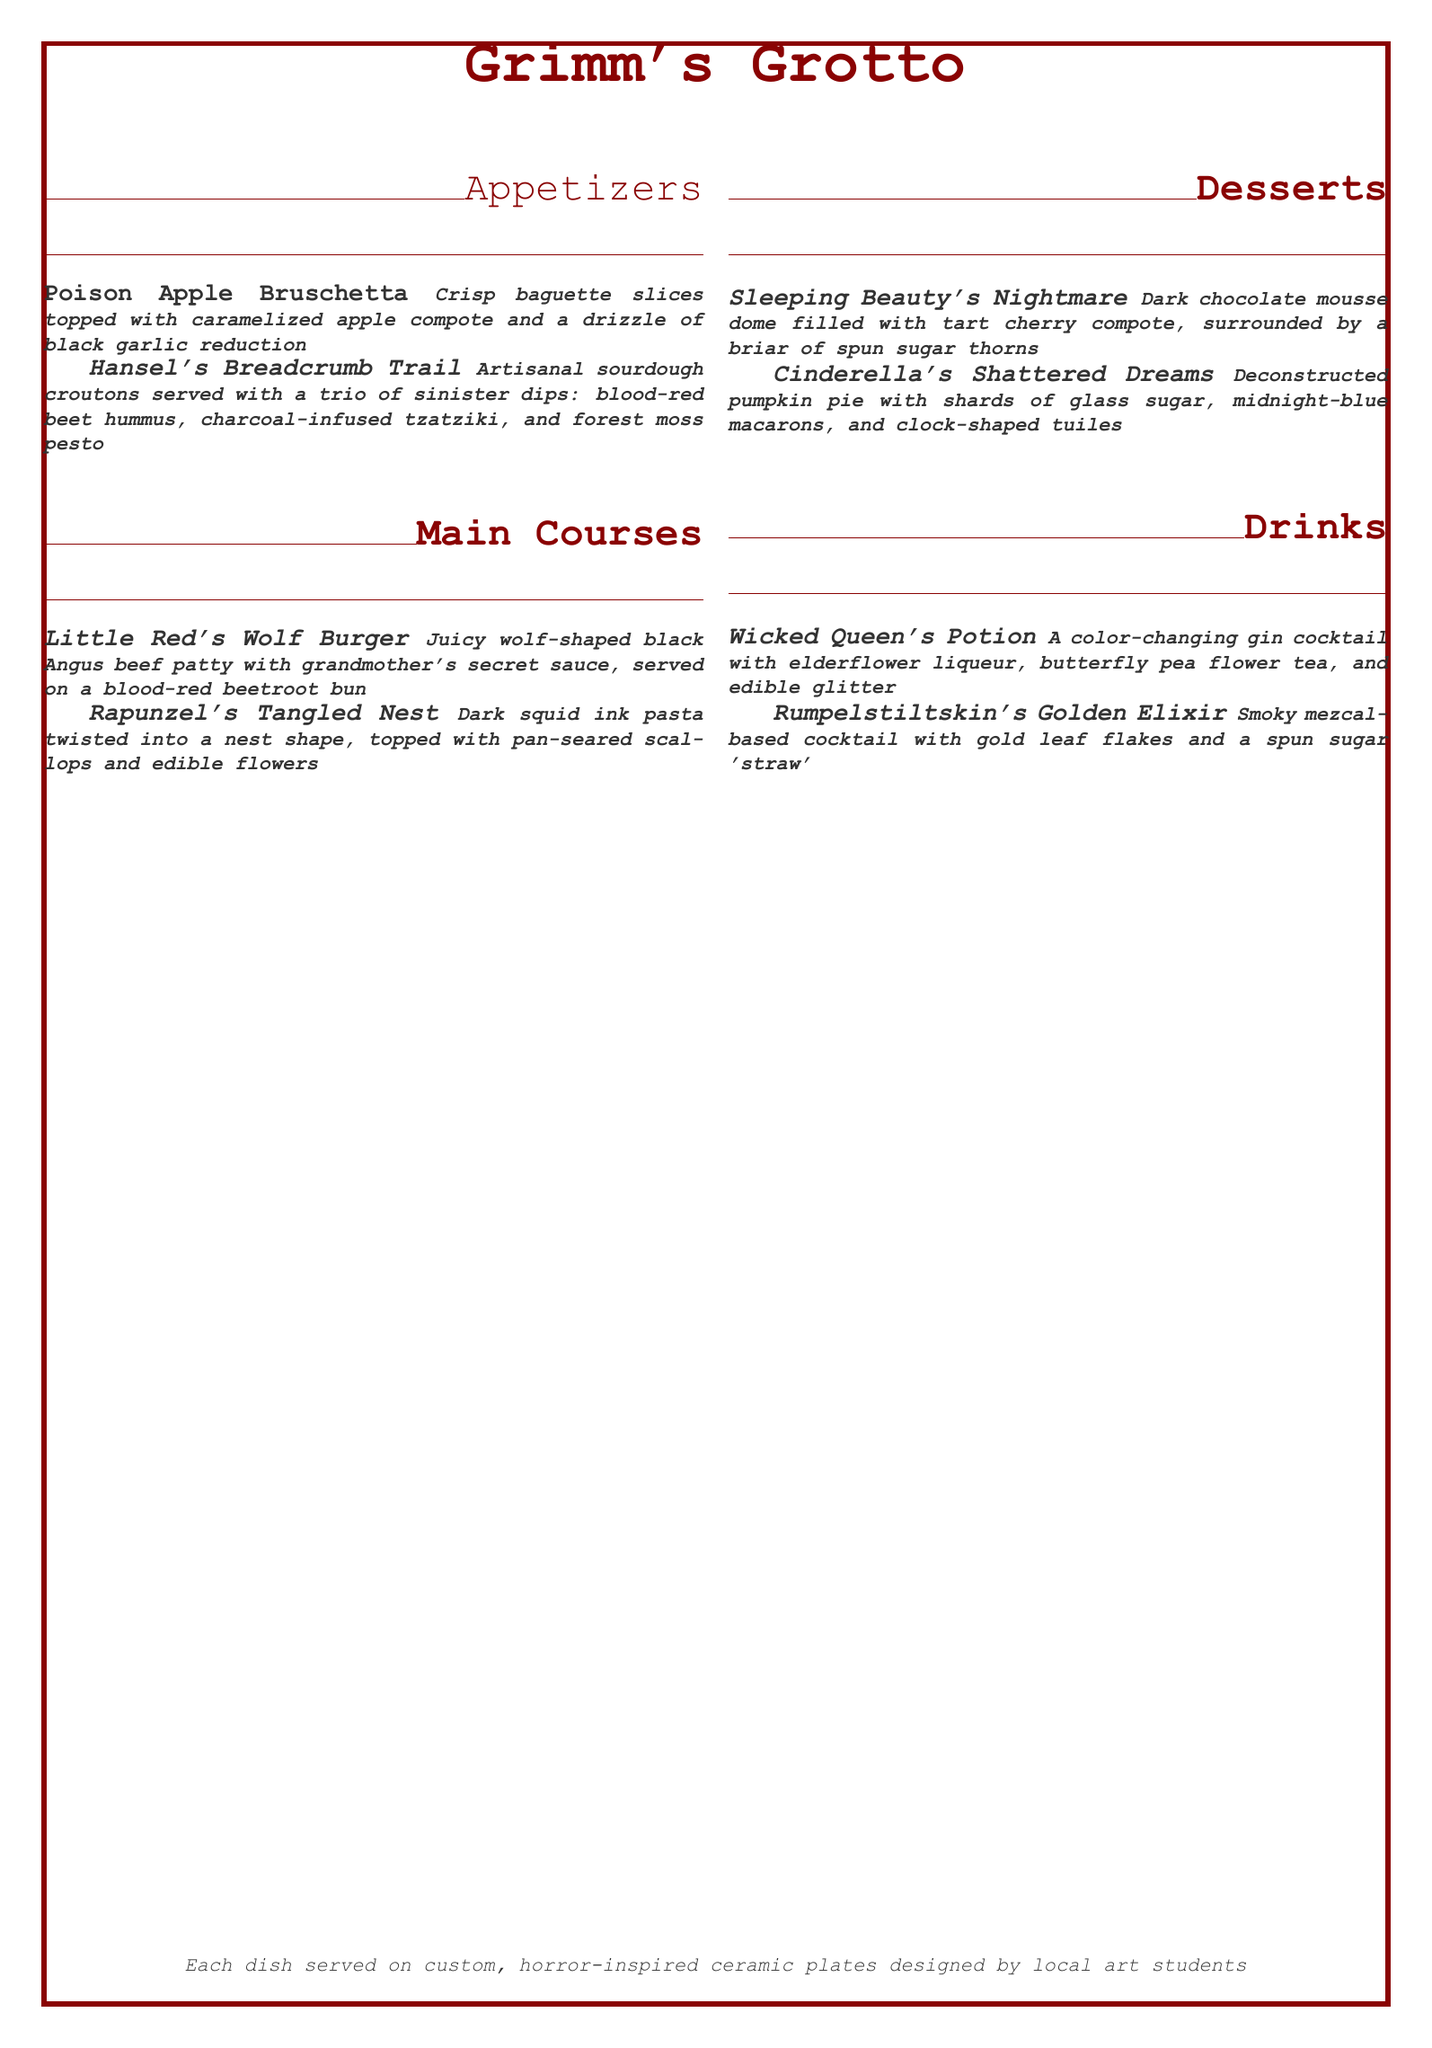What is the title of the menu? The title of the menu is prominently featured at the top of the document, which is Grimm's Grotto.
Answer: Grimm's Grotto How many sections are listed in the menu? The menu contains sections such as Appetizers, Main Courses, Desserts, and Drinks, which total four sections.
Answer: 4 What is included in the Little Red's Wolf Burger? The description of Little Red's Wolf Burger details a juicy beef patty with a specific ingredient, which is grandmother's secret sauce.
Answer: Grandmother's secret sauce What color is the beetroot bun served with the Little Red's Wolf Burger? The description explicitly states the color of the bun is blood-red.
Answer: Blood-red Which dessert features dark chocolate? The menu lists Sleeping Beauty's Nightmare as the dessert that contains dark chocolate.
Answer: Sleeping Beauty's Nightmare What type of pasta is used in Rapunzel's Tangled Nest? The specific ingredient that identifies the type of pasta is dark squid ink pasta.
Answer: Dark squid ink pasta What kind of cocktail is Wicked Queen's Potion? The document specifies that Wicked Queen's Potion is a color-changing gin cocktail.
Answer: Color-changing gin cocktail How is Cinderella's Shattered Dreams presented? The dessert is described as deconstructed, indicating its presentation style.
Answer: Deconstructed What unique feature do the dishes have according to the menu? The menu mentions that the dishes are served on custom, horror-inspired ceramic plates.
Answer: Custom, horror-inspired ceramic plates 